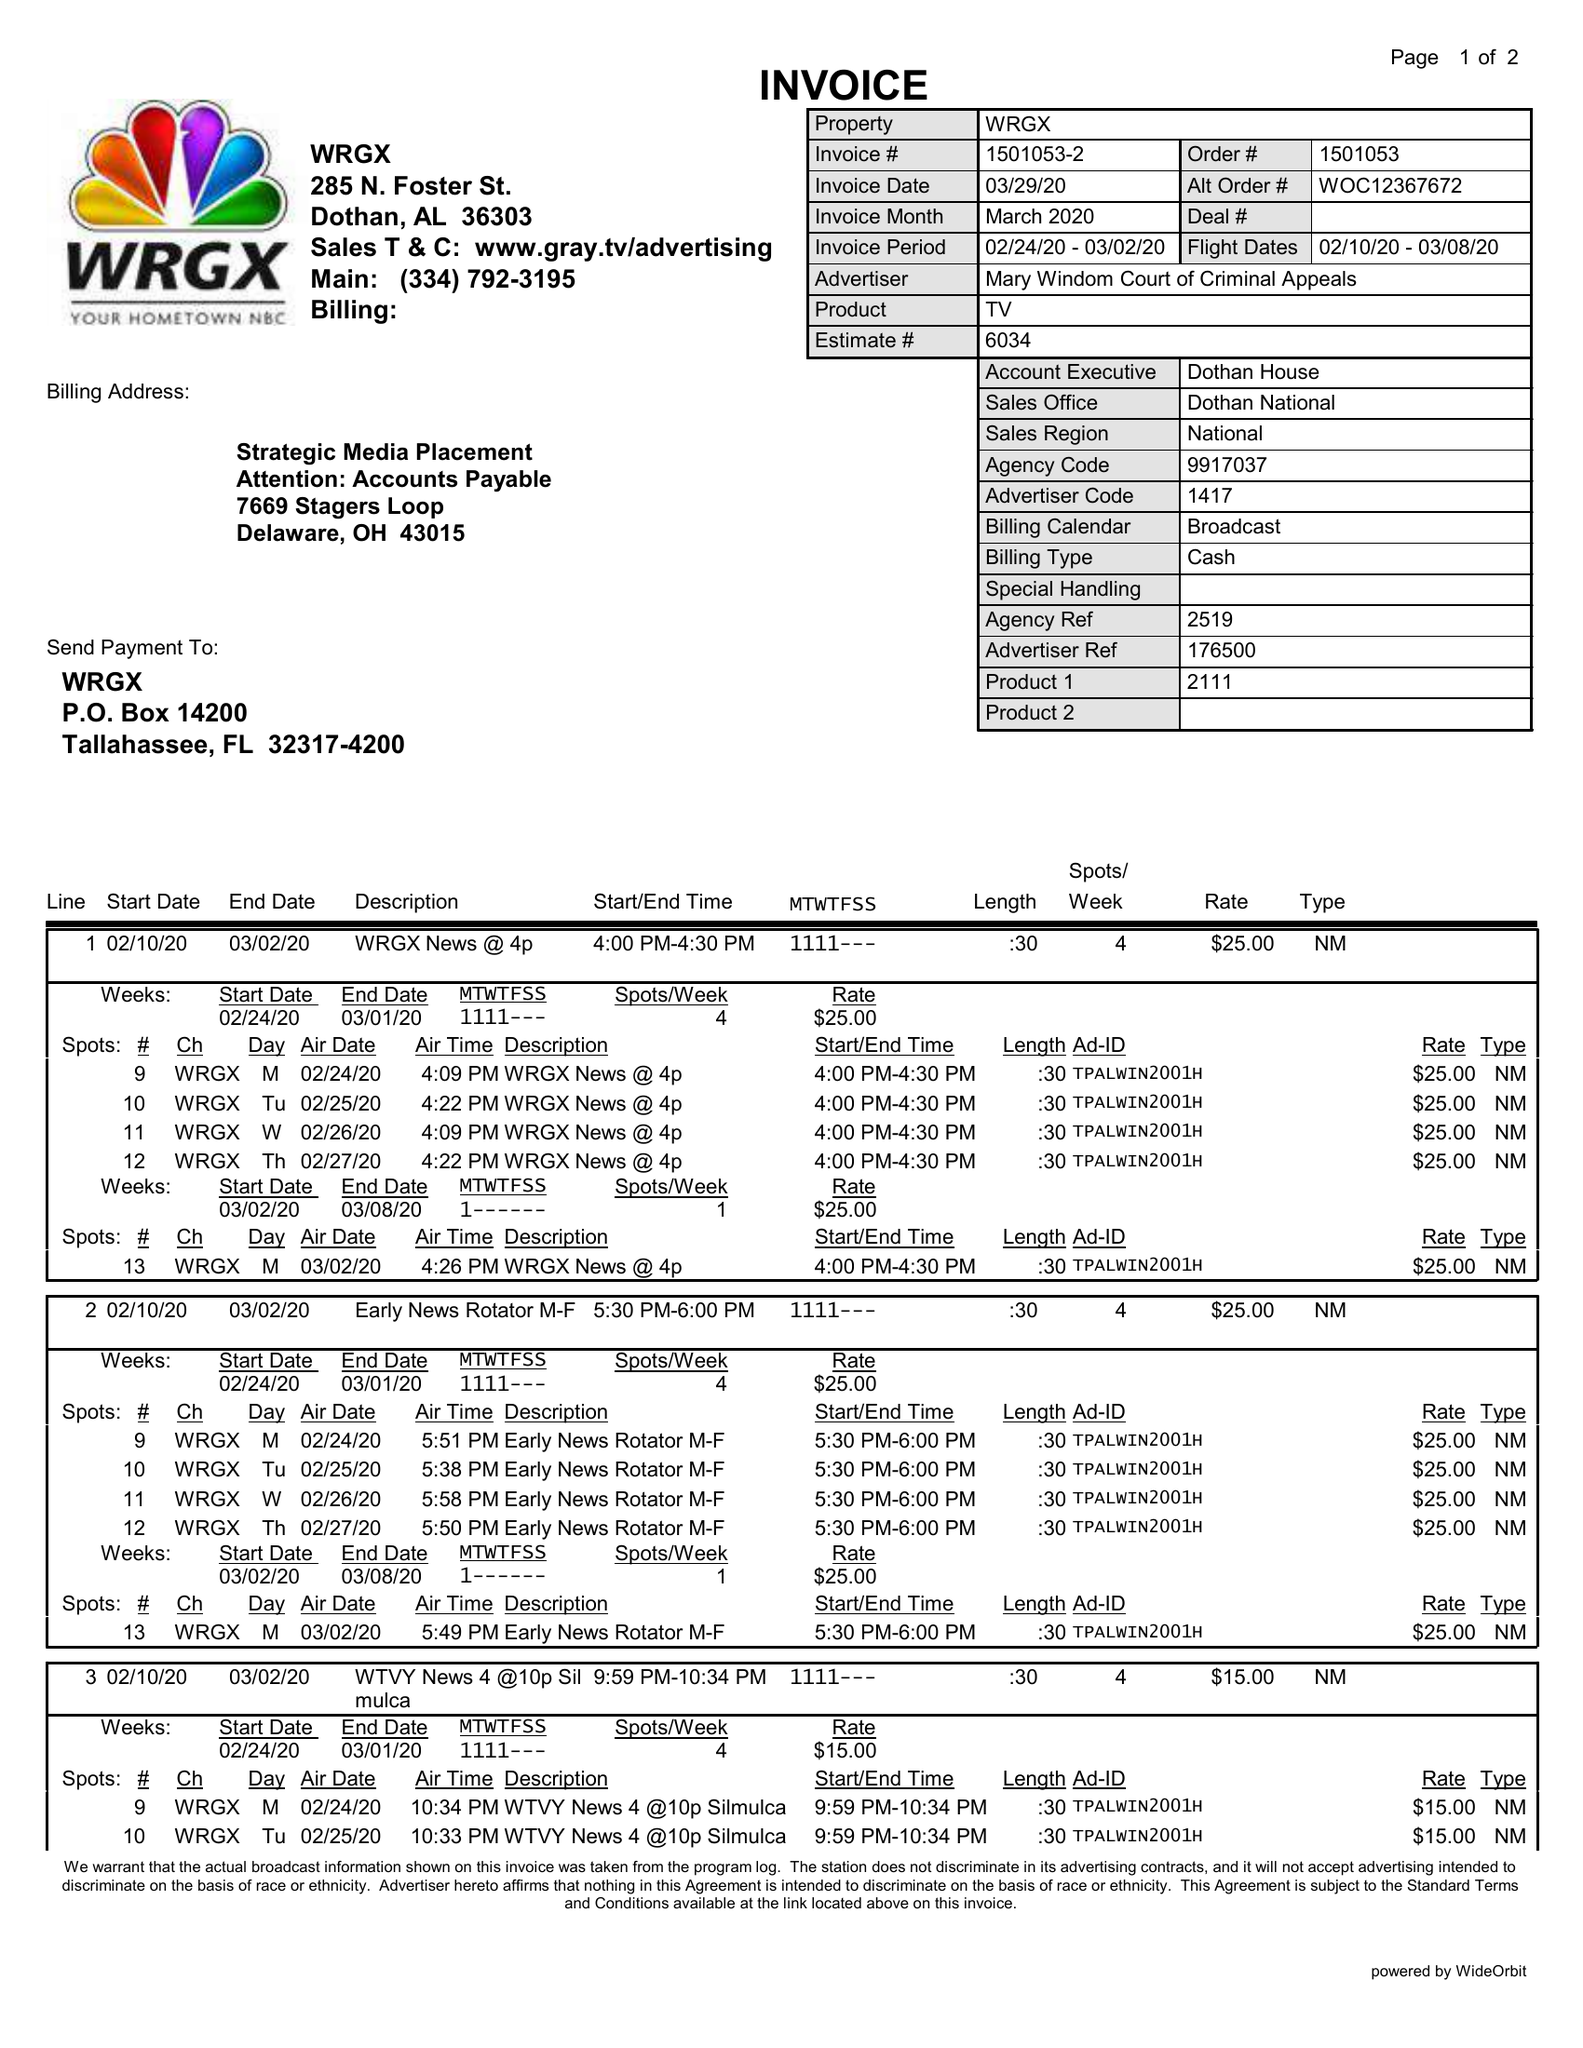What is the value for the flight_to?
Answer the question using a single word or phrase. 03/08/20 